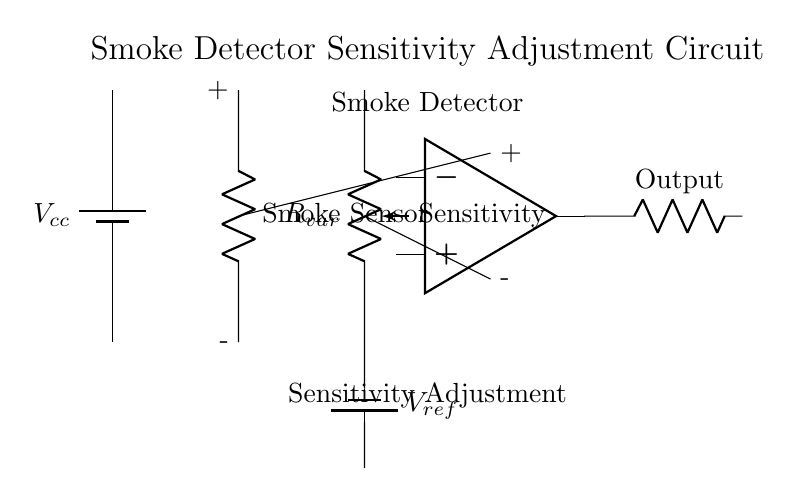What component is used for sensitivity adjustment? The variable resistor labeled as Sensitivity in the circuit diagram functions for sensitivity adjustment, allowing the user to tune the response of the smoke detector.
Answer: Sensitivity What is the function of the comparator in this circuit? The comparator receives inputs from the smoke sensor and the variable resistor, comparing these values to determine if an alarm condition exists, hence its role in processing the signals from these components.
Answer: Alarm signal processing What is the purpose of the smoke sensor? The smoke sensor detects the presence of smoke and provides a corresponding resistance change that affects the voltage level at the input of the comparator.
Answer: Smoke detection What type of power supply is used in the circuit? The circuit utilizes a battery as its power supply, as indicated by the battery symbol labeled as Vcc in the diagram.
Answer: Battery How does the sensitivity adjustment impact the operation of the smoke detector? Adjusting the variable resistor alters the amount of current flowing through the circuit, changing the voltage at the comparator's input, which can lower or heighten the detector's response to smoke presence.
Answer: Changes the detector's responsiveness What is the labeled reference voltage in this circuit? The reference voltage is denoted by Vref, which provides a standard against which the voltage from the smoke sensor is compared by the comparator.
Answer: Vref Which component provides the output signal in this circuit? The output signal is produced by the comparator, which is shown in the diagram directing its output to a resistor labeled as Output.
Answer: Comparator 